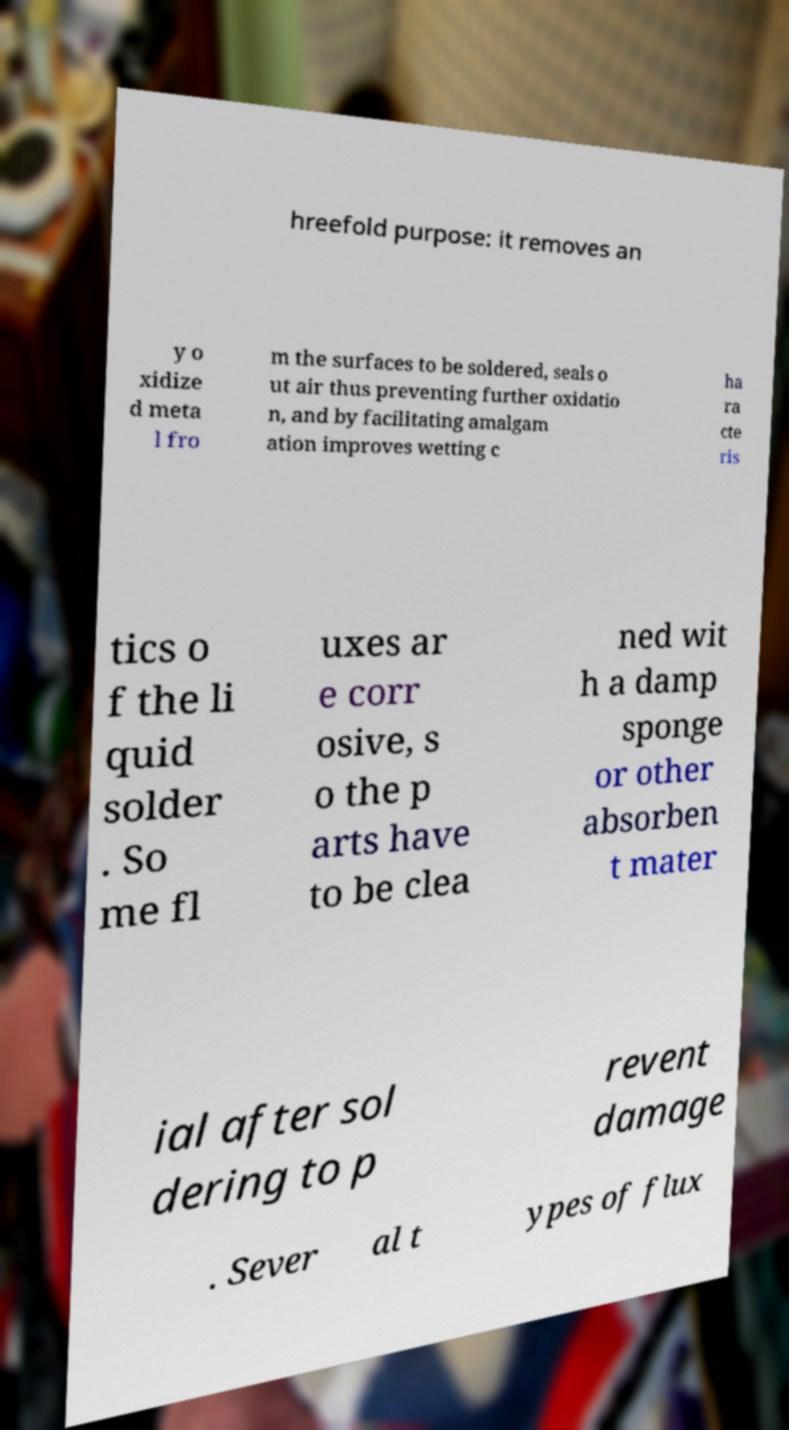Can you accurately transcribe the text from the provided image for me? hreefold purpose: it removes an y o xidize d meta l fro m the surfaces to be soldered, seals o ut air thus preventing further oxidatio n, and by facilitating amalgam ation improves wetting c ha ra cte ris tics o f the li quid solder . So me fl uxes ar e corr osive, s o the p arts have to be clea ned wit h a damp sponge or other absorben t mater ial after sol dering to p revent damage . Sever al t ypes of flux 